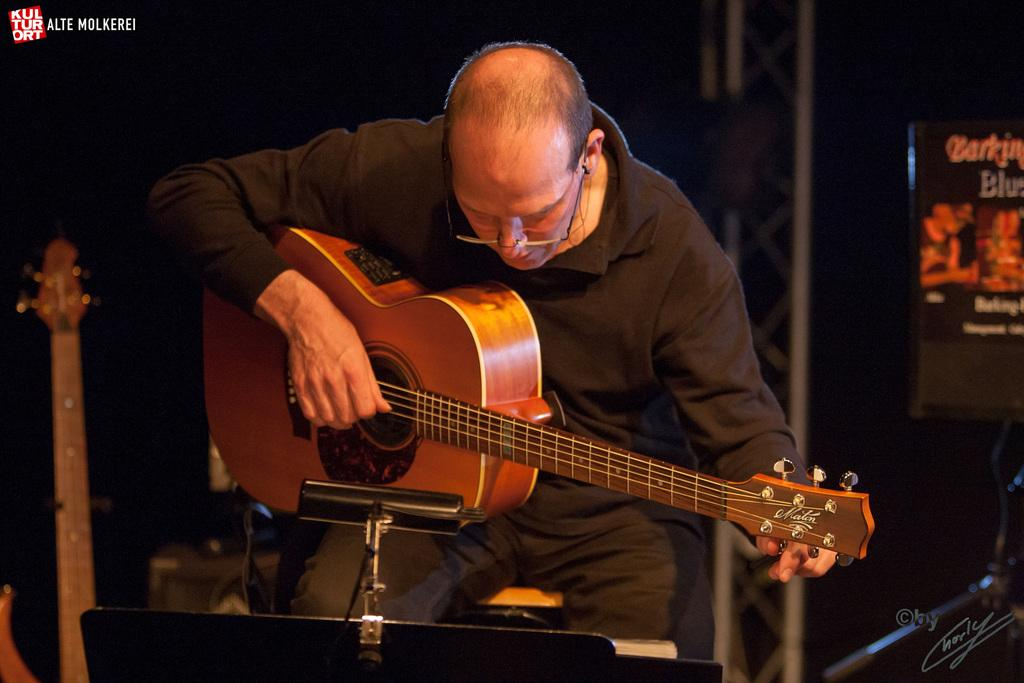Who is the person in the image? There is a man in the image. What is the man doing in the image? The man is sitting on a stool and playing the guitar. What is the man's posture while playing the guitar? The man is looking downwards while playing the guitar. What other guitar can be seen in the image? There is a guitar placed on the left side of the image. How many baseballs can be seen in the image? There are no baseballs present in the image. What is the height of the man in the image? The provided facts do not mention the man's height, so it cannot be determined from the image. 